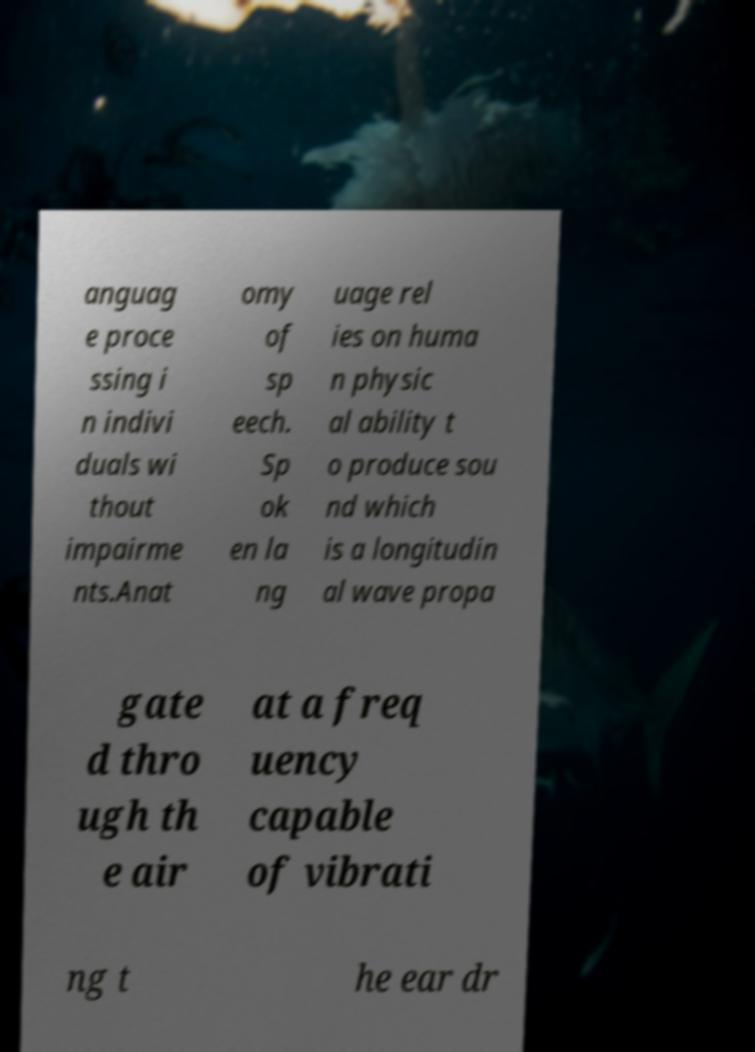Please identify and transcribe the text found in this image. anguag e proce ssing i n indivi duals wi thout impairme nts.Anat omy of sp eech. Sp ok en la ng uage rel ies on huma n physic al ability t o produce sou nd which is a longitudin al wave propa gate d thro ugh th e air at a freq uency capable of vibrati ng t he ear dr 